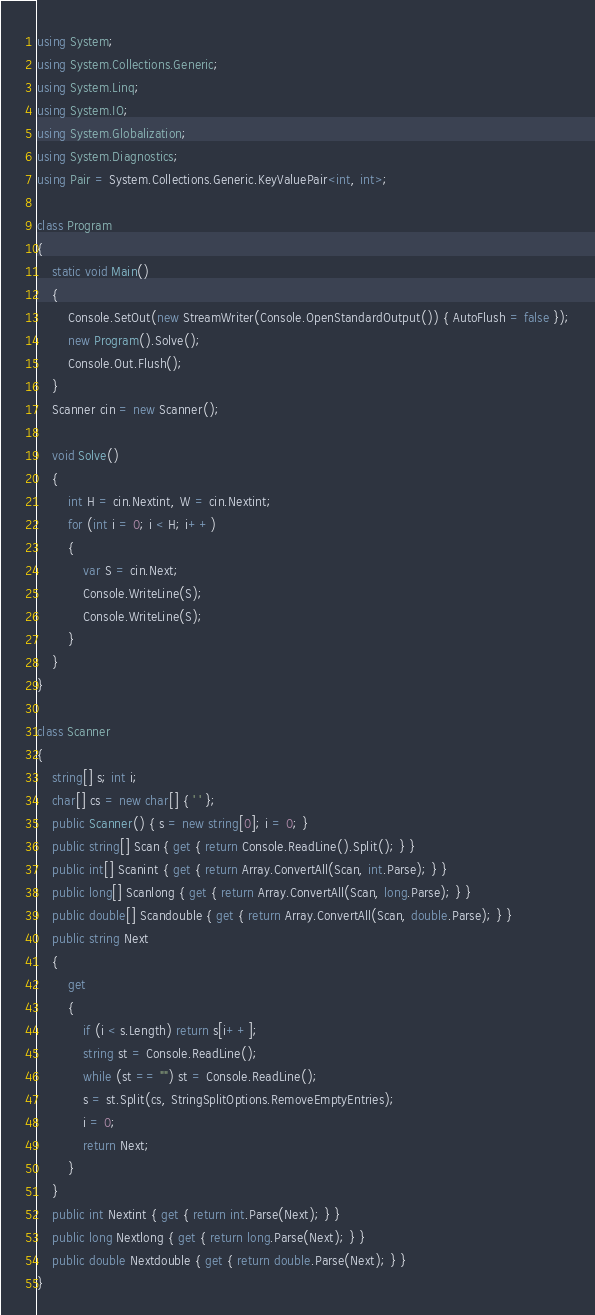Convert code to text. <code><loc_0><loc_0><loc_500><loc_500><_C#_>using System;
using System.Collections.Generic;
using System.Linq;
using System.IO;
using System.Globalization;
using System.Diagnostics;
using Pair = System.Collections.Generic.KeyValuePair<int, int>;

class Program
{
    static void Main()
    {
        Console.SetOut(new StreamWriter(Console.OpenStandardOutput()) { AutoFlush = false });
        new Program().Solve();
        Console.Out.Flush();
    }
    Scanner cin = new Scanner();

    void Solve()
    {
        int H = cin.Nextint, W = cin.Nextint;
        for (int i = 0; i < H; i++)
        {
            var S = cin.Next;
            Console.WriteLine(S);
            Console.WriteLine(S);
        }
    }
}

class Scanner
{
    string[] s; int i;
    char[] cs = new char[] { ' ' };
    public Scanner() { s = new string[0]; i = 0; }
    public string[] Scan { get { return Console.ReadLine().Split(); } }
    public int[] Scanint { get { return Array.ConvertAll(Scan, int.Parse); } }
    public long[] Scanlong { get { return Array.ConvertAll(Scan, long.Parse); } }
    public double[] Scandouble { get { return Array.ConvertAll(Scan, double.Parse); } }
    public string Next
    {
        get
        {
            if (i < s.Length) return s[i++];
            string st = Console.ReadLine();
            while (st == "") st = Console.ReadLine();
            s = st.Split(cs, StringSplitOptions.RemoveEmptyEntries);
            i = 0;
            return Next;
        }
    }
    public int Nextint { get { return int.Parse(Next); } }
    public long Nextlong { get { return long.Parse(Next); } }
    public double Nextdouble { get { return double.Parse(Next); } }
}</code> 